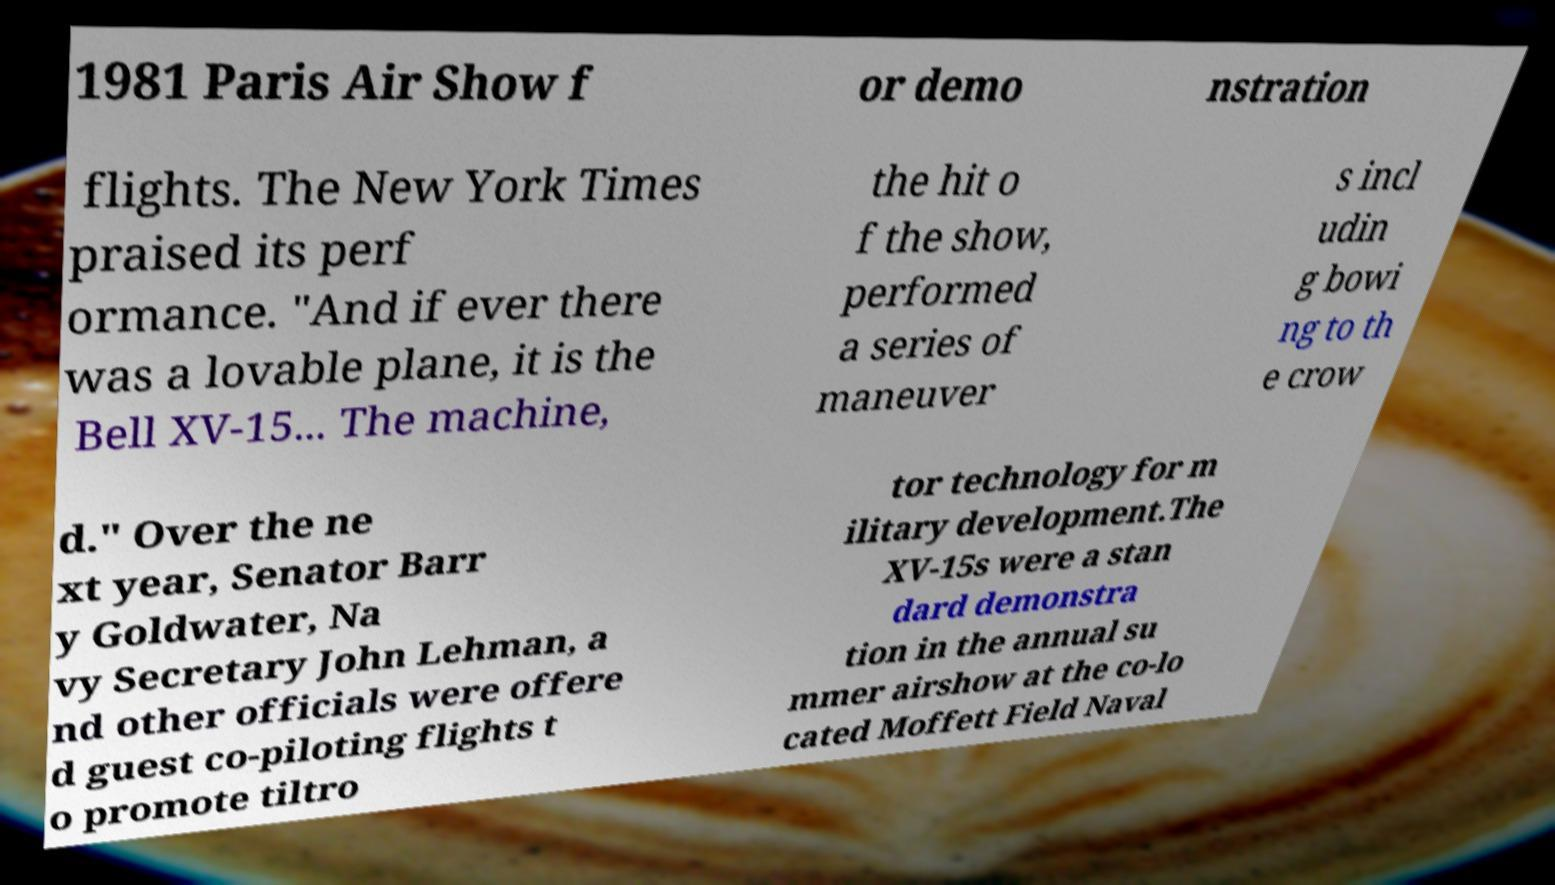Can you read and provide the text displayed in the image?This photo seems to have some interesting text. Can you extract and type it out for me? 1981 Paris Air Show f or demo nstration flights. The New York Times praised its perf ormance. "And if ever there was a lovable plane, it is the Bell XV-15... The machine, the hit o f the show, performed a series of maneuver s incl udin g bowi ng to th e crow d." Over the ne xt year, Senator Barr y Goldwater, Na vy Secretary John Lehman, a nd other officials were offere d guest co-piloting flights t o promote tiltro tor technology for m ilitary development.The XV-15s were a stan dard demonstra tion in the annual su mmer airshow at the co-lo cated Moffett Field Naval 